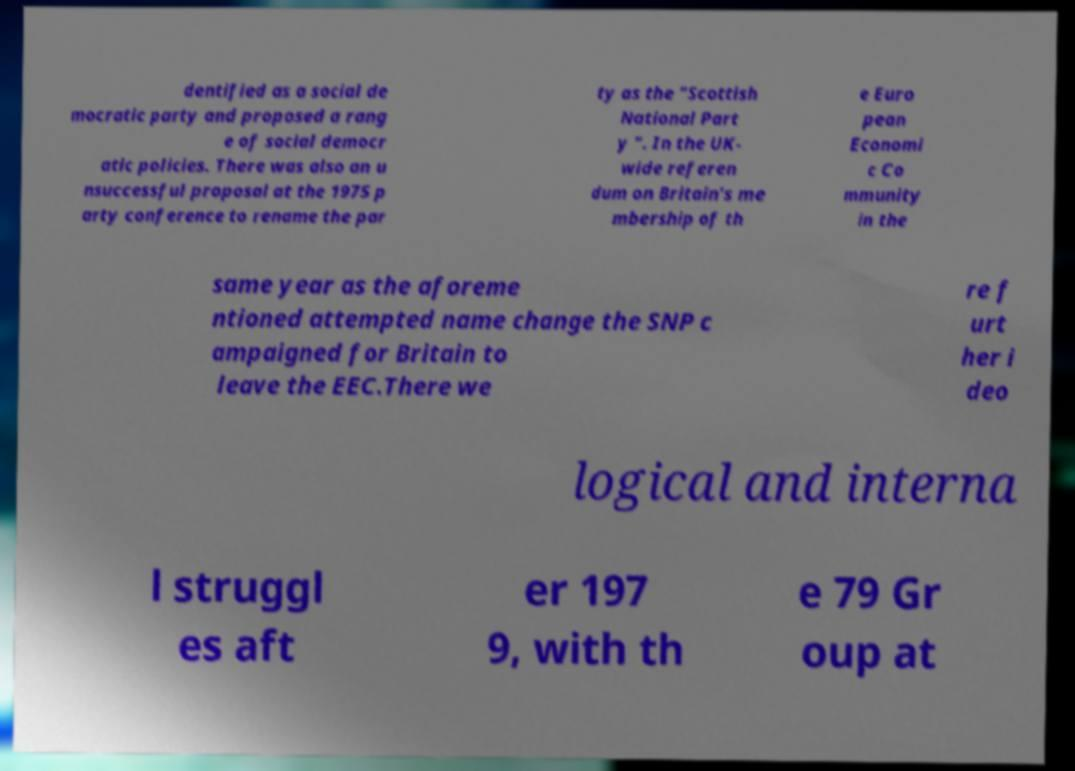I need the written content from this picture converted into text. Can you do that? dentified as a social de mocratic party and proposed a rang e of social democr atic policies. There was also an u nsuccessful proposal at the 1975 p arty conference to rename the par ty as the "Scottish National Part y ". In the UK- wide referen dum on Britain's me mbership of th e Euro pean Economi c Co mmunity in the same year as the aforeme ntioned attempted name change the SNP c ampaigned for Britain to leave the EEC.There we re f urt her i deo logical and interna l struggl es aft er 197 9, with th e 79 Gr oup at 